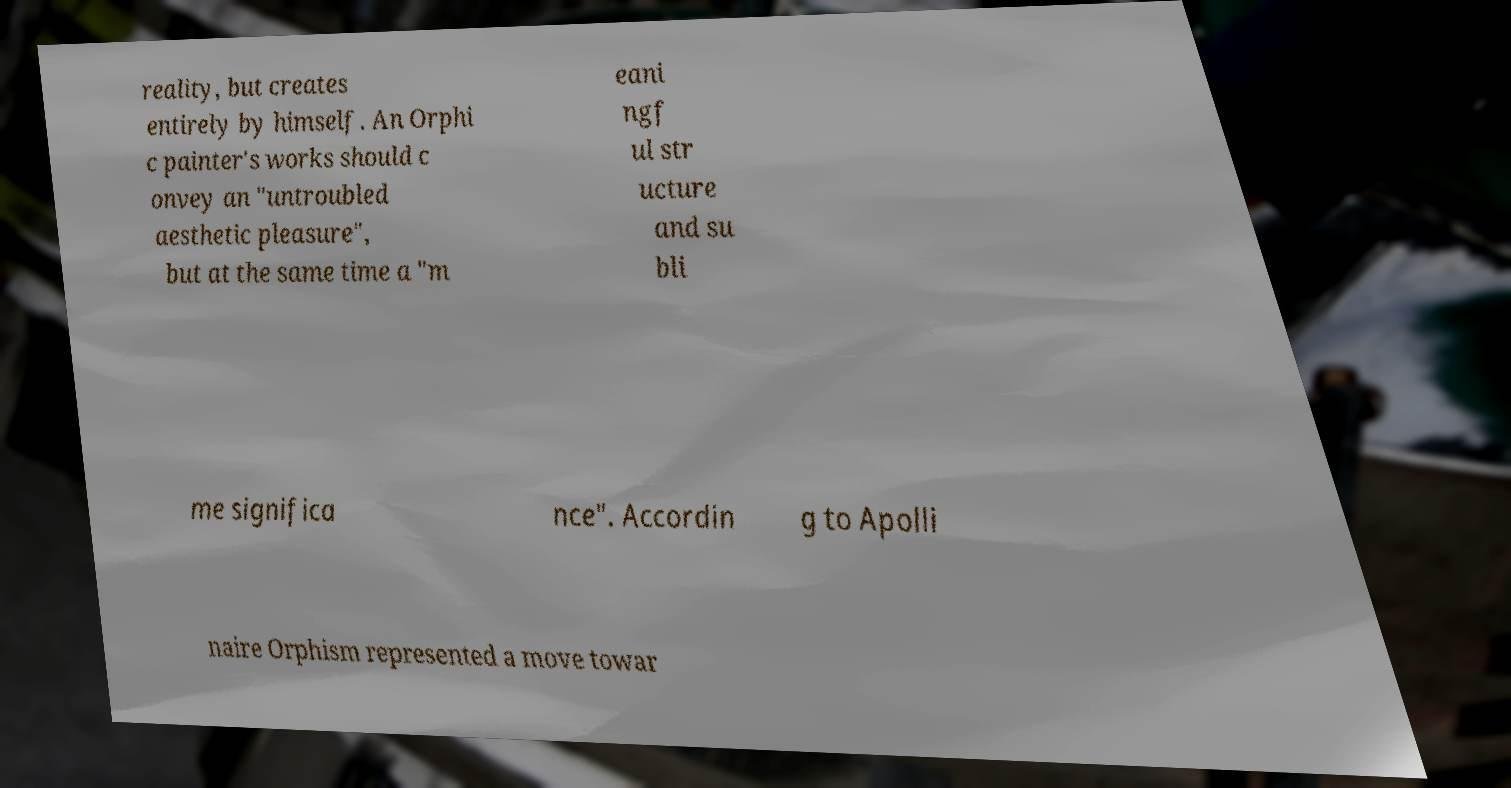I need the written content from this picture converted into text. Can you do that? reality, but creates entirely by himself. An Orphi c painter's works should c onvey an "untroubled aesthetic pleasure", but at the same time a "m eani ngf ul str ucture and su bli me significa nce". Accordin g to Apolli naire Orphism represented a move towar 